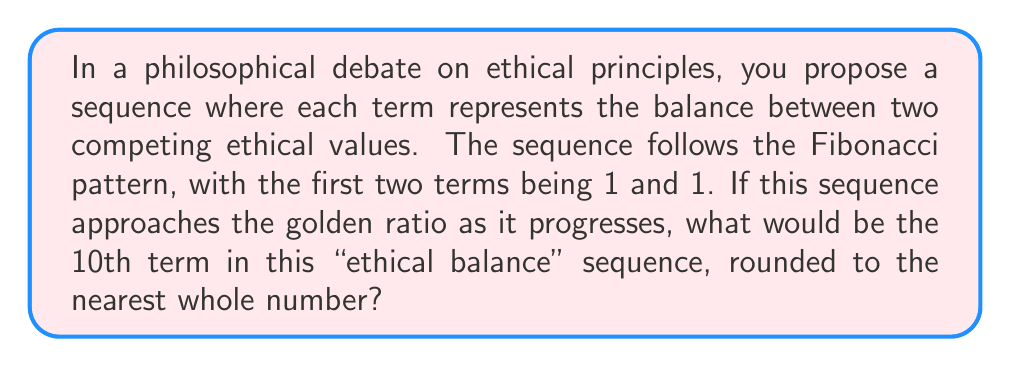Can you answer this question? Let's approach this step-by-step:

1) First, recall the Fibonacci sequence: 1, 1, 2, 3, 5, 8, 13, 21, 34, 55, ...

2) Each term after the first two is the sum of the two preceding terms:
   $F_n = F_{n-1} + F_{n-2}$

3) The golden ratio, often denoted by $\phi$, is approximately 1.618034...

4) As the Fibonacci sequence progresses, the ratio of consecutive terms approaches the golden ratio:

   $\lim_{n \to \infty} \frac{F_{n+1}}{F_n} = \phi$

5) To find the 10th term, we simply need to calculate the first 10 terms of the Fibonacci sequence:

   $F_1 = 1$
   $F_2 = 1$
   $F_3 = F_2 + F_1 = 1 + 1 = 2$
   $F_4 = F_3 + F_2 = 2 + 1 = 3$
   $F_5 = F_4 + F_3 = 3 + 2 = 5$
   $F_6 = F_5 + F_4 = 5 + 3 = 8$
   $F_7 = F_6 + F_5 = 8 + 5 = 13$
   $F_8 = F_7 + F_6 = 13 + 8 = 21$
   $F_9 = F_8 + F_7 = 21 + 13 = 34$
   $F_{10} = F_9 + F_8 = 34 + 21 = 55$

6) Therefore, the 10th term in the sequence is 55.

7) This sequence symbolizes the balance of ethical principles as it approaches the golden ratio, which is often associated with aesthetic beauty and natural balance. Each term represents a more refined balance between competing ethical values.
Answer: 55 